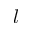Convert formula to latex. <formula><loc_0><loc_0><loc_500><loc_500>l</formula> 